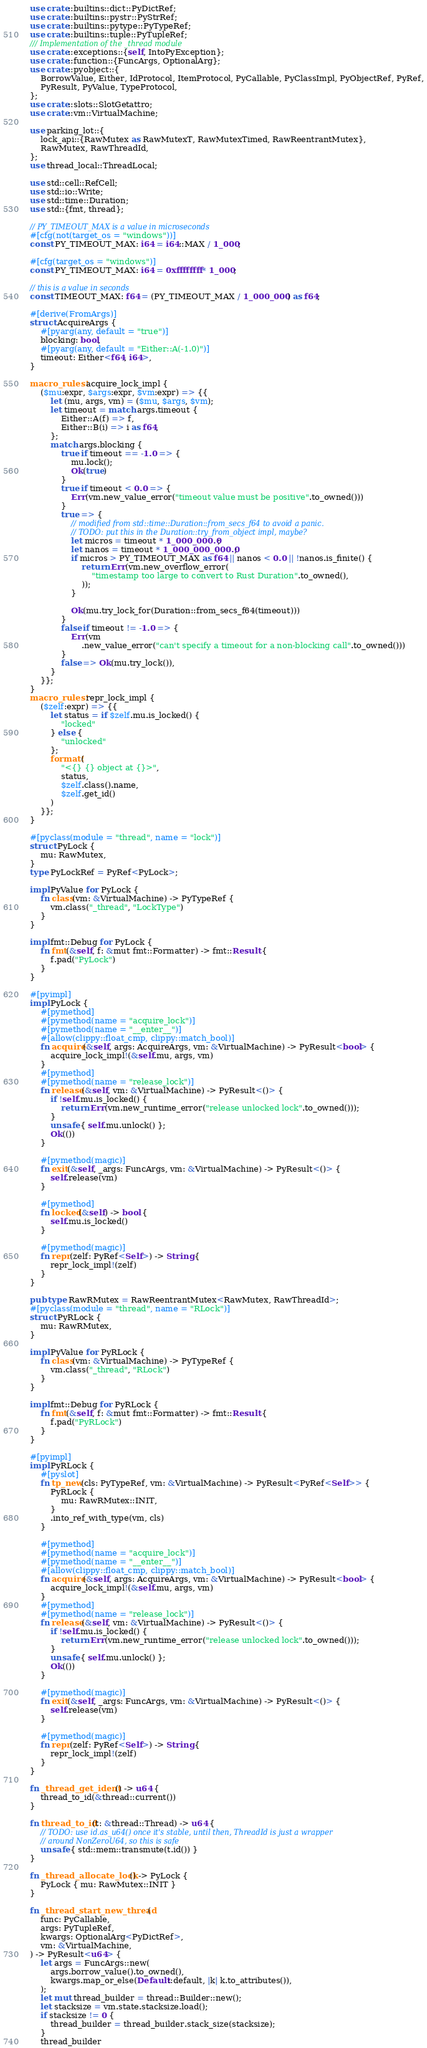<code> <loc_0><loc_0><loc_500><loc_500><_Rust_>use crate::builtins::dict::PyDictRef;
use crate::builtins::pystr::PyStrRef;
use crate::builtins::pytype::PyTypeRef;
use crate::builtins::tuple::PyTupleRef;
/// Implementation of the _thread module
use crate::exceptions::{self, IntoPyException};
use crate::function::{FuncArgs, OptionalArg};
use crate::pyobject::{
    BorrowValue, Either, IdProtocol, ItemProtocol, PyCallable, PyClassImpl, PyObjectRef, PyRef,
    PyResult, PyValue, TypeProtocol,
};
use crate::slots::SlotGetattro;
use crate::vm::VirtualMachine;

use parking_lot::{
    lock_api::{RawMutex as RawMutexT, RawMutexTimed, RawReentrantMutex},
    RawMutex, RawThreadId,
};
use thread_local::ThreadLocal;

use std::cell::RefCell;
use std::io::Write;
use std::time::Duration;
use std::{fmt, thread};

// PY_TIMEOUT_MAX is a value in microseconds
#[cfg(not(target_os = "windows"))]
const PY_TIMEOUT_MAX: i64 = i64::MAX / 1_000;

#[cfg(target_os = "windows")]
const PY_TIMEOUT_MAX: i64 = 0xffffffff * 1_000;

// this is a value in seconds
const TIMEOUT_MAX: f64 = (PY_TIMEOUT_MAX / 1_000_000) as f64;

#[derive(FromArgs)]
struct AcquireArgs {
    #[pyarg(any, default = "true")]
    blocking: bool,
    #[pyarg(any, default = "Either::A(-1.0)")]
    timeout: Either<f64, i64>,
}

macro_rules! acquire_lock_impl {
    ($mu:expr, $args:expr, $vm:expr) => {{
        let (mu, args, vm) = ($mu, $args, $vm);
        let timeout = match args.timeout {
            Either::A(f) => f,
            Either::B(i) => i as f64,
        };
        match args.blocking {
            true if timeout == -1.0 => {
                mu.lock();
                Ok(true)
            }
            true if timeout < 0.0 => {
                Err(vm.new_value_error("timeout value must be positive".to_owned()))
            }
            true => {
                // modified from std::time::Duration::from_secs_f64 to avoid a panic.
                // TODO: put this in the Duration::try_from_object impl, maybe?
                let micros = timeout * 1_000_000.0;
                let nanos = timeout * 1_000_000_000.0;
                if micros > PY_TIMEOUT_MAX as f64 || nanos < 0.0 || !nanos.is_finite() {
                    return Err(vm.new_overflow_error(
                        "timestamp too large to convert to Rust Duration".to_owned(),
                    ));
                }

                Ok(mu.try_lock_for(Duration::from_secs_f64(timeout)))
            }
            false if timeout != -1.0 => {
                Err(vm
                    .new_value_error("can't specify a timeout for a non-blocking call".to_owned()))
            }
            false => Ok(mu.try_lock()),
        }
    }};
}
macro_rules! repr_lock_impl {
    ($zelf:expr) => {{
        let status = if $zelf.mu.is_locked() {
            "locked"
        } else {
            "unlocked"
        };
        format!(
            "<{} {} object at {}>",
            status,
            $zelf.class().name,
            $zelf.get_id()
        )
    }};
}

#[pyclass(module = "thread", name = "lock")]
struct PyLock {
    mu: RawMutex,
}
type PyLockRef = PyRef<PyLock>;

impl PyValue for PyLock {
    fn class(vm: &VirtualMachine) -> PyTypeRef {
        vm.class("_thread", "LockType")
    }
}

impl fmt::Debug for PyLock {
    fn fmt(&self, f: &mut fmt::Formatter) -> fmt::Result {
        f.pad("PyLock")
    }
}

#[pyimpl]
impl PyLock {
    #[pymethod]
    #[pymethod(name = "acquire_lock")]
    #[pymethod(name = "__enter__")]
    #[allow(clippy::float_cmp, clippy::match_bool)]
    fn acquire(&self, args: AcquireArgs, vm: &VirtualMachine) -> PyResult<bool> {
        acquire_lock_impl!(&self.mu, args, vm)
    }
    #[pymethod]
    #[pymethod(name = "release_lock")]
    fn release(&self, vm: &VirtualMachine) -> PyResult<()> {
        if !self.mu.is_locked() {
            return Err(vm.new_runtime_error("release unlocked lock".to_owned()));
        }
        unsafe { self.mu.unlock() };
        Ok(())
    }

    #[pymethod(magic)]
    fn exit(&self, _args: FuncArgs, vm: &VirtualMachine) -> PyResult<()> {
        self.release(vm)
    }

    #[pymethod]
    fn locked(&self) -> bool {
        self.mu.is_locked()
    }

    #[pymethod(magic)]
    fn repr(zelf: PyRef<Self>) -> String {
        repr_lock_impl!(zelf)
    }
}

pub type RawRMutex = RawReentrantMutex<RawMutex, RawThreadId>;
#[pyclass(module = "thread", name = "RLock")]
struct PyRLock {
    mu: RawRMutex,
}

impl PyValue for PyRLock {
    fn class(vm: &VirtualMachine) -> PyTypeRef {
        vm.class("_thread", "RLock")
    }
}

impl fmt::Debug for PyRLock {
    fn fmt(&self, f: &mut fmt::Formatter) -> fmt::Result {
        f.pad("PyRLock")
    }
}

#[pyimpl]
impl PyRLock {
    #[pyslot]
    fn tp_new(cls: PyTypeRef, vm: &VirtualMachine) -> PyResult<PyRef<Self>> {
        PyRLock {
            mu: RawRMutex::INIT,
        }
        .into_ref_with_type(vm, cls)
    }

    #[pymethod]
    #[pymethod(name = "acquire_lock")]
    #[pymethod(name = "__enter__")]
    #[allow(clippy::float_cmp, clippy::match_bool)]
    fn acquire(&self, args: AcquireArgs, vm: &VirtualMachine) -> PyResult<bool> {
        acquire_lock_impl!(&self.mu, args, vm)
    }
    #[pymethod]
    #[pymethod(name = "release_lock")]
    fn release(&self, vm: &VirtualMachine) -> PyResult<()> {
        if !self.mu.is_locked() {
            return Err(vm.new_runtime_error("release unlocked lock".to_owned()));
        }
        unsafe { self.mu.unlock() };
        Ok(())
    }

    #[pymethod(magic)]
    fn exit(&self, _args: FuncArgs, vm: &VirtualMachine) -> PyResult<()> {
        self.release(vm)
    }

    #[pymethod(magic)]
    fn repr(zelf: PyRef<Self>) -> String {
        repr_lock_impl!(zelf)
    }
}

fn _thread_get_ident() -> u64 {
    thread_to_id(&thread::current())
}

fn thread_to_id(t: &thread::Thread) -> u64 {
    // TODO: use id.as_u64() once it's stable, until then, ThreadId is just a wrapper
    // around NonZeroU64, so this is safe
    unsafe { std::mem::transmute(t.id()) }
}

fn _thread_allocate_lock() -> PyLock {
    PyLock { mu: RawMutex::INIT }
}

fn _thread_start_new_thread(
    func: PyCallable,
    args: PyTupleRef,
    kwargs: OptionalArg<PyDictRef>,
    vm: &VirtualMachine,
) -> PyResult<u64> {
    let args = FuncArgs::new(
        args.borrow_value().to_owned(),
        kwargs.map_or_else(Default::default, |k| k.to_attributes()),
    );
    let mut thread_builder = thread::Builder::new();
    let stacksize = vm.state.stacksize.load();
    if stacksize != 0 {
        thread_builder = thread_builder.stack_size(stacksize);
    }
    thread_builder</code> 